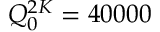<formula> <loc_0><loc_0><loc_500><loc_500>Q _ { 0 } ^ { 2 K } = 4 0 0 0 0</formula> 